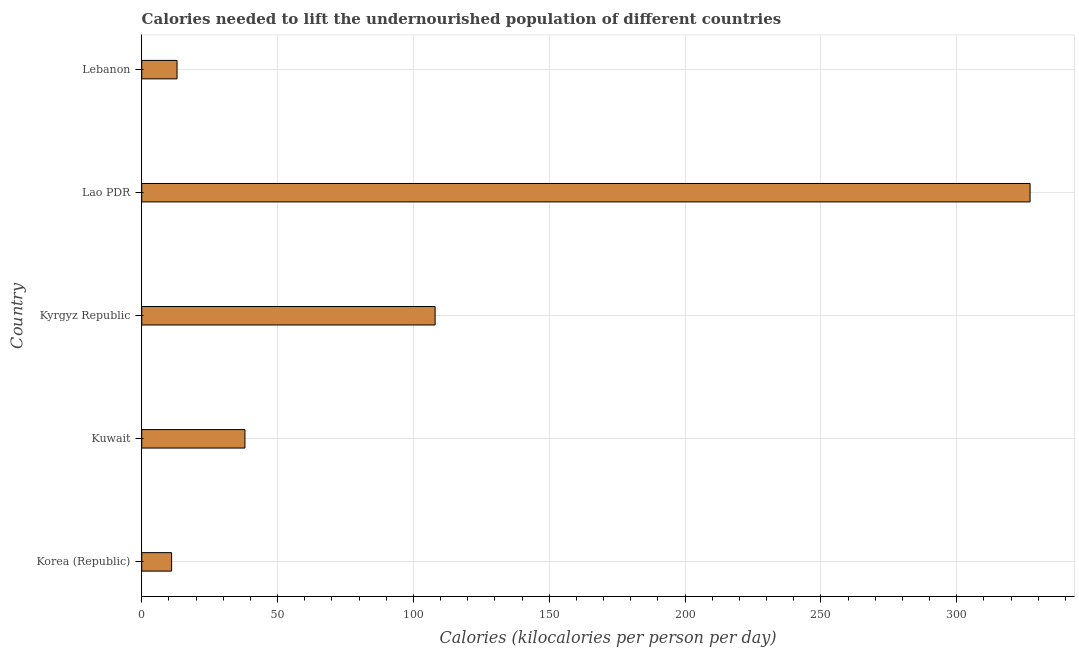What is the title of the graph?
Provide a short and direct response. Calories needed to lift the undernourished population of different countries. What is the label or title of the X-axis?
Your response must be concise. Calories (kilocalories per person per day). What is the label or title of the Y-axis?
Offer a terse response. Country. What is the depth of food deficit in Kuwait?
Your answer should be very brief. 38. Across all countries, what is the maximum depth of food deficit?
Make the answer very short. 327. Across all countries, what is the minimum depth of food deficit?
Your response must be concise. 11. In which country was the depth of food deficit maximum?
Give a very brief answer. Lao PDR. In which country was the depth of food deficit minimum?
Give a very brief answer. Korea (Republic). What is the sum of the depth of food deficit?
Ensure brevity in your answer.  497. What is the difference between the depth of food deficit in Lao PDR and Lebanon?
Keep it short and to the point. 314. What is the average depth of food deficit per country?
Offer a very short reply. 99.4. What is the ratio of the depth of food deficit in Kyrgyz Republic to that in Lao PDR?
Your answer should be compact. 0.33. Is the depth of food deficit in Korea (Republic) less than that in Kyrgyz Republic?
Your answer should be compact. Yes. Is the difference between the depth of food deficit in Lao PDR and Lebanon greater than the difference between any two countries?
Offer a very short reply. No. What is the difference between the highest and the second highest depth of food deficit?
Provide a succinct answer. 219. What is the difference between the highest and the lowest depth of food deficit?
Your answer should be very brief. 316. In how many countries, is the depth of food deficit greater than the average depth of food deficit taken over all countries?
Your response must be concise. 2. How many bars are there?
Give a very brief answer. 5. Are the values on the major ticks of X-axis written in scientific E-notation?
Offer a very short reply. No. What is the Calories (kilocalories per person per day) of Korea (Republic)?
Provide a succinct answer. 11. What is the Calories (kilocalories per person per day) in Kuwait?
Your answer should be compact. 38. What is the Calories (kilocalories per person per day) in Kyrgyz Republic?
Your answer should be very brief. 108. What is the Calories (kilocalories per person per day) of Lao PDR?
Your response must be concise. 327. What is the Calories (kilocalories per person per day) in Lebanon?
Your response must be concise. 13. What is the difference between the Calories (kilocalories per person per day) in Korea (Republic) and Kyrgyz Republic?
Your answer should be compact. -97. What is the difference between the Calories (kilocalories per person per day) in Korea (Republic) and Lao PDR?
Provide a short and direct response. -316. What is the difference between the Calories (kilocalories per person per day) in Kuwait and Kyrgyz Republic?
Provide a succinct answer. -70. What is the difference between the Calories (kilocalories per person per day) in Kuwait and Lao PDR?
Keep it short and to the point. -289. What is the difference between the Calories (kilocalories per person per day) in Kuwait and Lebanon?
Provide a succinct answer. 25. What is the difference between the Calories (kilocalories per person per day) in Kyrgyz Republic and Lao PDR?
Offer a terse response. -219. What is the difference between the Calories (kilocalories per person per day) in Lao PDR and Lebanon?
Provide a succinct answer. 314. What is the ratio of the Calories (kilocalories per person per day) in Korea (Republic) to that in Kuwait?
Your answer should be very brief. 0.29. What is the ratio of the Calories (kilocalories per person per day) in Korea (Republic) to that in Kyrgyz Republic?
Keep it short and to the point. 0.1. What is the ratio of the Calories (kilocalories per person per day) in Korea (Republic) to that in Lao PDR?
Your response must be concise. 0.03. What is the ratio of the Calories (kilocalories per person per day) in Korea (Republic) to that in Lebanon?
Ensure brevity in your answer.  0.85. What is the ratio of the Calories (kilocalories per person per day) in Kuwait to that in Kyrgyz Republic?
Your answer should be compact. 0.35. What is the ratio of the Calories (kilocalories per person per day) in Kuwait to that in Lao PDR?
Your answer should be very brief. 0.12. What is the ratio of the Calories (kilocalories per person per day) in Kuwait to that in Lebanon?
Provide a succinct answer. 2.92. What is the ratio of the Calories (kilocalories per person per day) in Kyrgyz Republic to that in Lao PDR?
Make the answer very short. 0.33. What is the ratio of the Calories (kilocalories per person per day) in Kyrgyz Republic to that in Lebanon?
Keep it short and to the point. 8.31. What is the ratio of the Calories (kilocalories per person per day) in Lao PDR to that in Lebanon?
Your answer should be very brief. 25.15. 